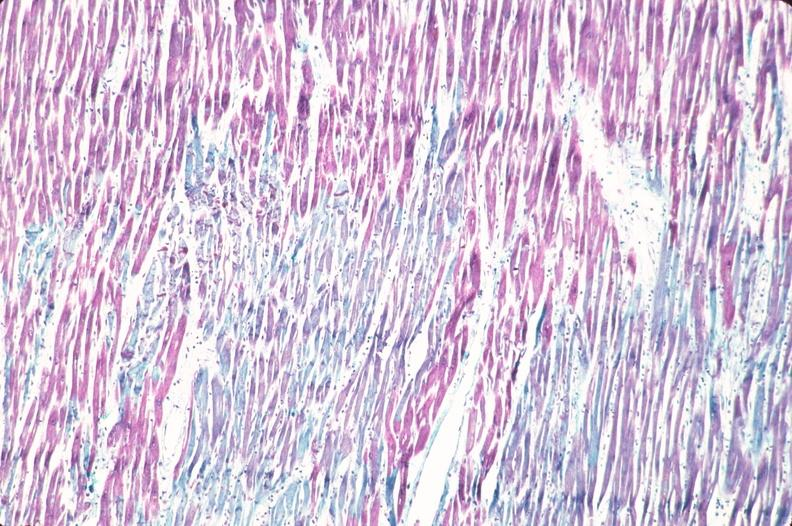do mitotic figures stain?
Answer the question using a single word or phrase. No 